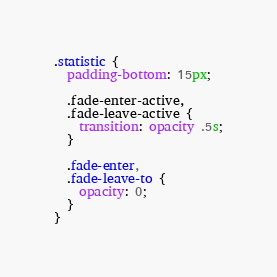Convert code to text. <code><loc_0><loc_0><loc_500><loc_500><_CSS_>.statistic {
  padding-bottom: 15px;

  .fade-enter-active,
  .fade-leave-active {
    transition: opacity .5s;
  }

  .fade-enter,
  .fade-leave-to {
    opacity: 0;
  }
}
</code> 